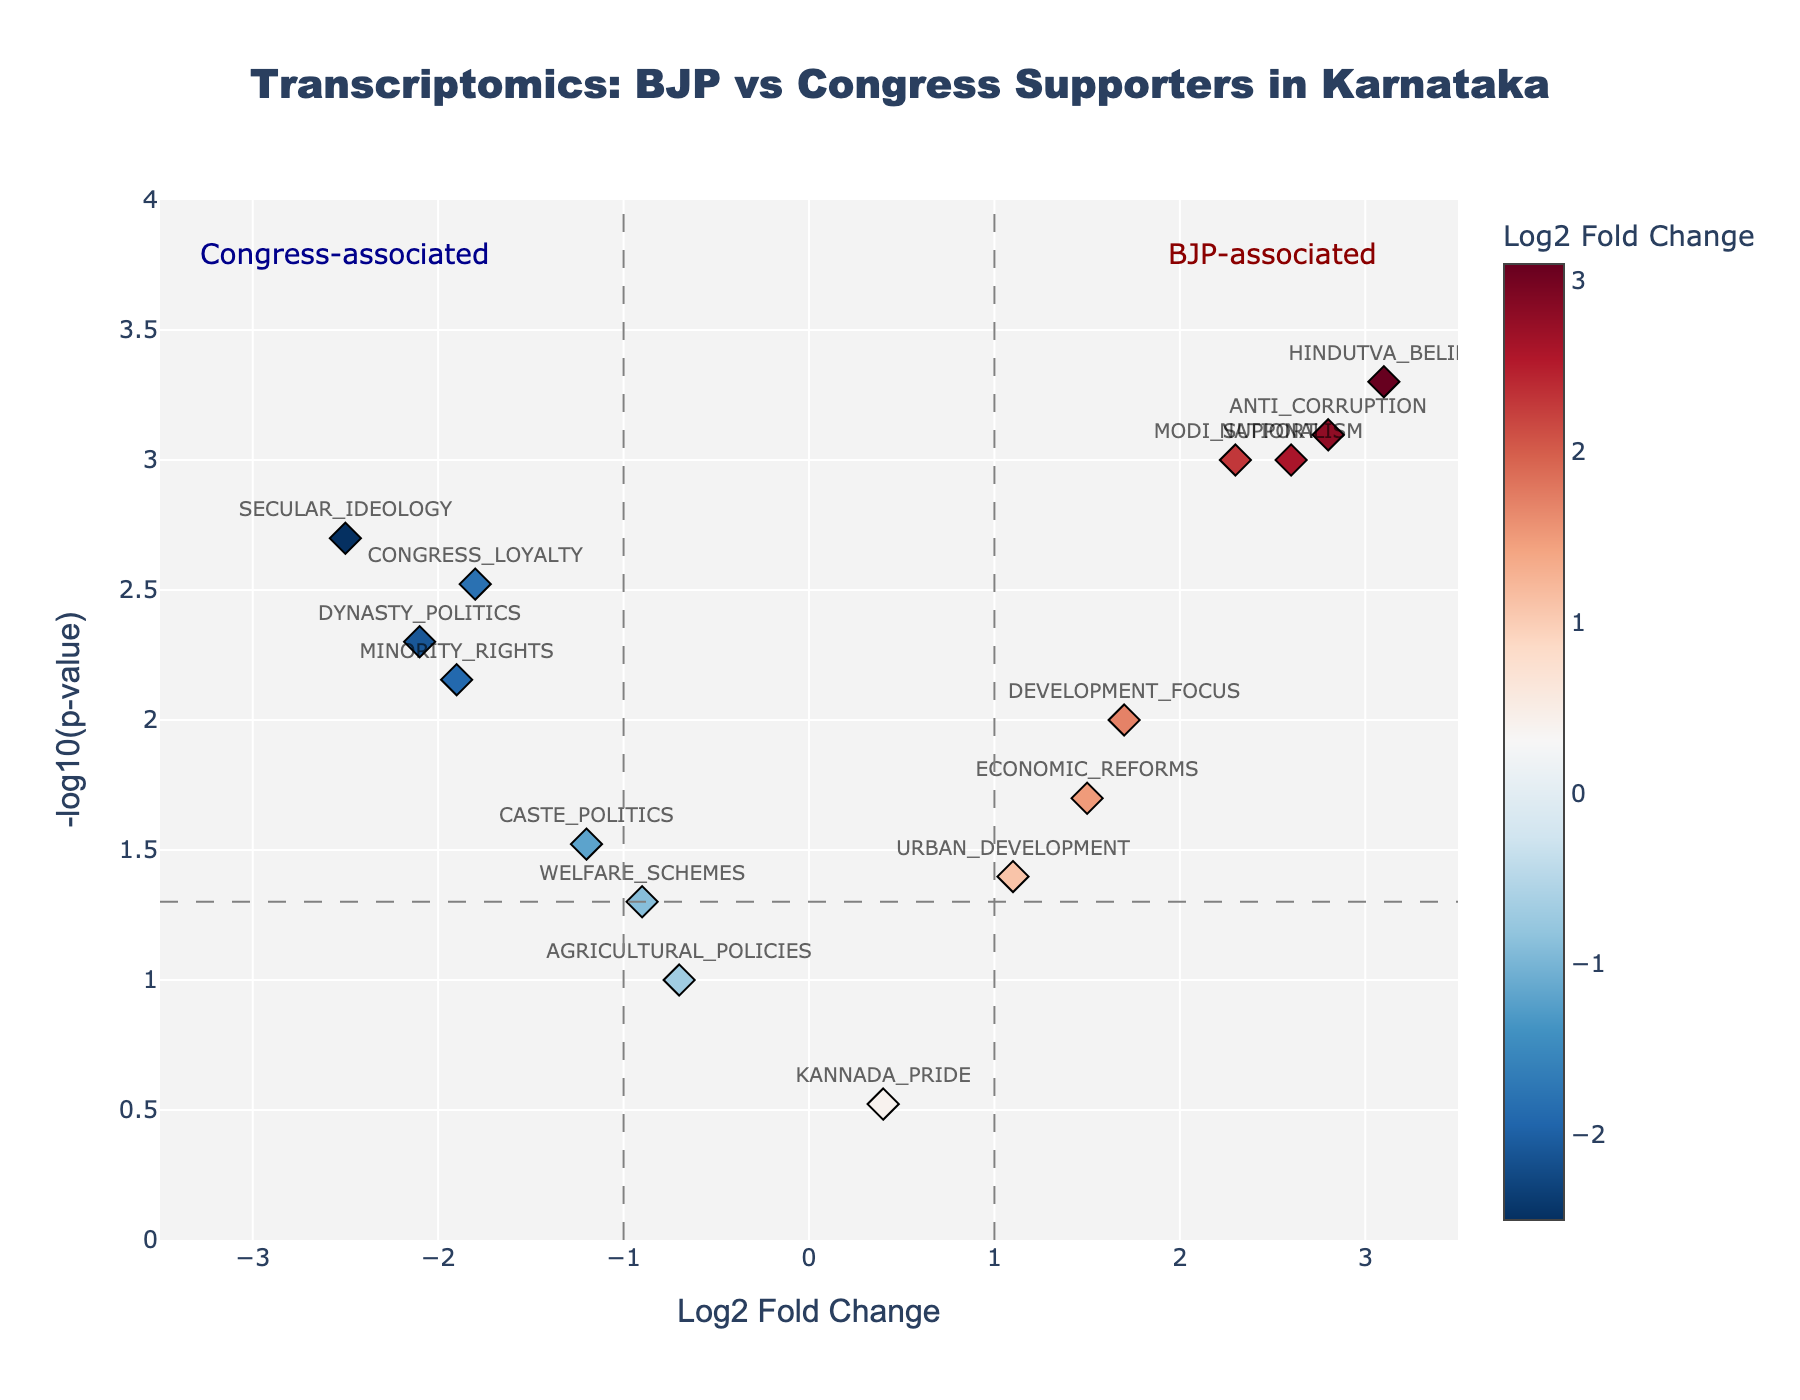What is the title of the figure? The title of the figure is displayed at the top of the plot. Just read it directly from the title text.
Answer: Transcriptomics: BJP vs Congress Supporters in Karnataka How many genes have a positive Log2 Fold Change? To determine this, count the number of data points on the right side of the y-axis (Log2 Fold Change > 0).
Answer: 7 Which gene has the highest Log2 Fold Change? Identify the gene with the maximum Log2FoldChange value on the x-axis.
Answer: HINDUTVA_BELIEF What is the threshold for significant p-values in this plot? Look at the horizontal dashed line and read the y-value where this line is located. This represents the -log10 of the p-value threshold.
Answer: 1.3 Which gene associated with Congress has the smallest p-value? Look for genes with negative Log2 Fold Change values and identify the one with the highest -log10(p-value) on the y-axis.
Answer: SECULAR_IDEOLOGY How many genes are associated with BJP based on both significance and Log2 Fold Change criteria? Count the number of genes that have Log2 Fold Change > 1 and -log10(p-value) > 1.3.
Answer: 4 Which gene has the lowest -log10(p-value) among those associated with Congress? Among genes with negative Log2 Fold Change values, find the one with the smallest -log10(p-value) on the y-axis.
Answer: WELFARE_SCHEMES Are most of the genes associated with BJP or Congress? Count the number of genes with positive Log2 Fold Change and compare it with the number of genes with negative Log2 Fold Change.
Answer: BJP What color indicates a higher Log2 Fold Change in this plot? Observe the color scale bar next to the plot and note which colors correspond to higher values on the Log2 Fold Change axis.
Answer: Red Which gene lies closest to the threshold line for Log2 Fold Change but remains significant in the context of BJP supporters? Identify the gene with positive Log2 Fold Change between 1 to 1.7 and -log10(p-value) > 1.3.
Answer: DEVELOPMENT_FOCUS 